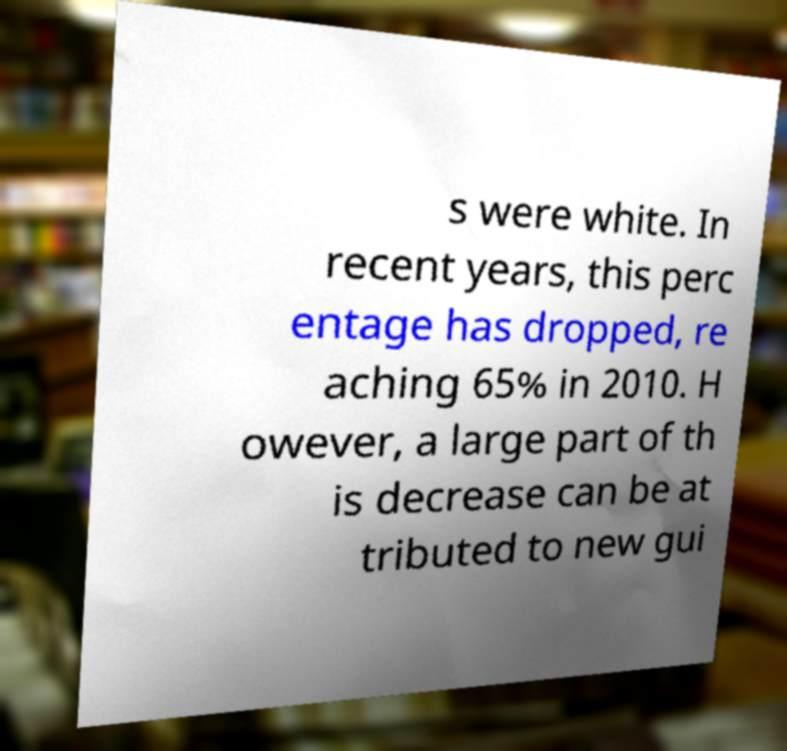What messages or text are displayed in this image? I need them in a readable, typed format. s were white. In recent years, this perc entage has dropped, re aching 65% in 2010. H owever, a large part of th is decrease can be at tributed to new gui 